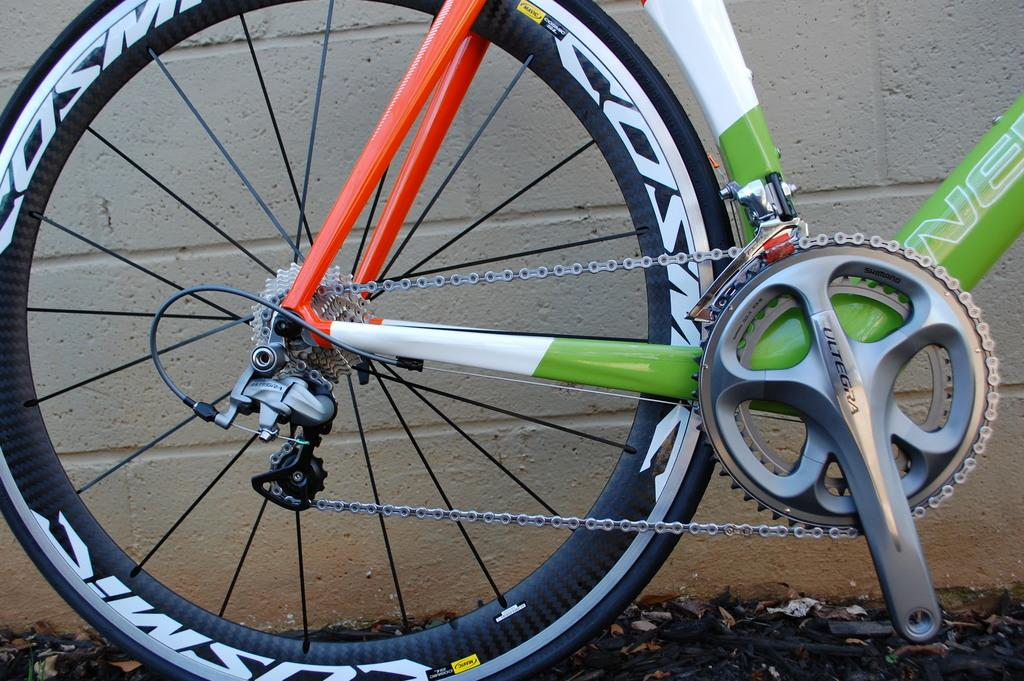What is the main object in the image? There is a cycle in the image. Where is the cycle located in relation to the image? The cycle is at the front of the image. What other element can be seen in the image? There is a wall in the image. How is the wall positioned in the image? The wall is at the back side of the image. How many toothbrushes are hanging on the wall in the image? There are no toothbrushes present in the image; it only features a cycle and a wall. 